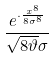<formula> <loc_0><loc_0><loc_500><loc_500>\frac { e ^ { \cdot \frac { x ^ { 8 } } { 8 \sigma ^ { 8 } } } } { \sqrt { 8 \vartheta } \sigma }</formula> 